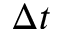Convert formula to latex. <formula><loc_0><loc_0><loc_500><loc_500>\Delta t</formula> 